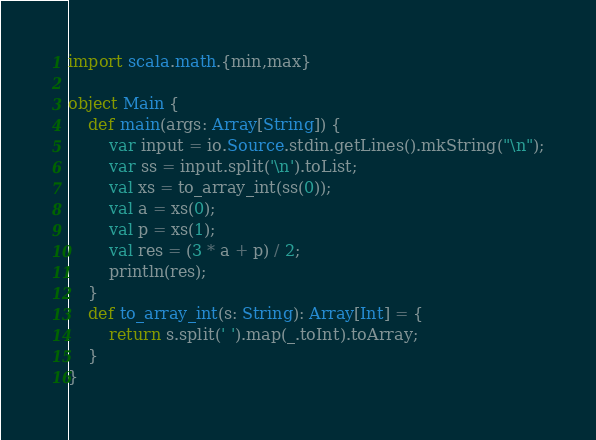<code> <loc_0><loc_0><loc_500><loc_500><_Scala_>import scala.math.{min,max}

object Main {
    def main(args: Array[String]) {
        var input = io.Source.stdin.getLines().mkString("\n");
        var ss = input.split('\n').toList;
        val xs = to_array_int(ss(0));
        val a = xs(0);
        val p = xs(1);
        val res = (3 * a + p) / 2;
        println(res);
    }
    def to_array_int(s: String): Array[Int] = {
        return s.split(' ').map(_.toInt).toArray;
    }
}
</code> 